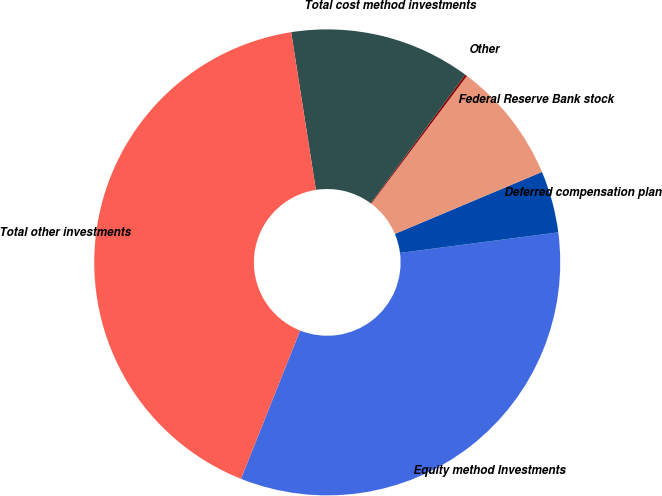Convert chart to OTSL. <chart><loc_0><loc_0><loc_500><loc_500><pie_chart><fcel>Equity method Investments<fcel>Deferred compensation plan<fcel>Federal Reserve Bank stock<fcel>Other<fcel>Total cost method investments<fcel>Total other investments<nl><fcel>33.09%<fcel>4.29%<fcel>8.42%<fcel>0.15%<fcel>12.56%<fcel>41.49%<nl></chart> 